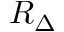<formula> <loc_0><loc_0><loc_500><loc_500>R _ { \Delta }</formula> 